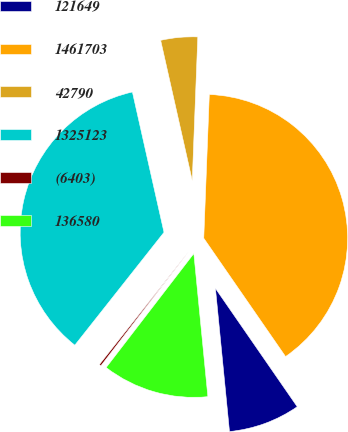<chart> <loc_0><loc_0><loc_500><loc_500><pie_chart><fcel>121649<fcel>1461703<fcel>42790<fcel>1325123<fcel>(6403)<fcel>136580<nl><fcel>8.07%<fcel>39.76%<fcel>4.14%<fcel>35.83%<fcel>0.21%<fcel>11.99%<nl></chart> 